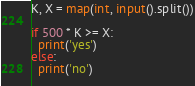Convert code to text. <code><loc_0><loc_0><loc_500><loc_500><_Python_>K, X = map(int, input().split())

if 500 * K >= X:
  print('yes')
else:
  print('no')
  
</code> 